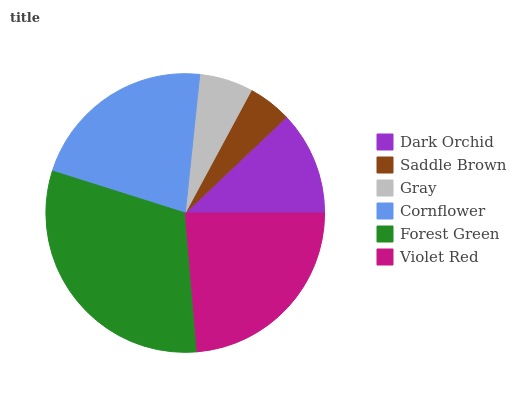Is Saddle Brown the minimum?
Answer yes or no. Yes. Is Forest Green the maximum?
Answer yes or no. Yes. Is Gray the minimum?
Answer yes or no. No. Is Gray the maximum?
Answer yes or no. No. Is Gray greater than Saddle Brown?
Answer yes or no. Yes. Is Saddle Brown less than Gray?
Answer yes or no. Yes. Is Saddle Brown greater than Gray?
Answer yes or no. No. Is Gray less than Saddle Brown?
Answer yes or no. No. Is Cornflower the high median?
Answer yes or no. Yes. Is Dark Orchid the low median?
Answer yes or no. Yes. Is Gray the high median?
Answer yes or no. No. Is Violet Red the low median?
Answer yes or no. No. 